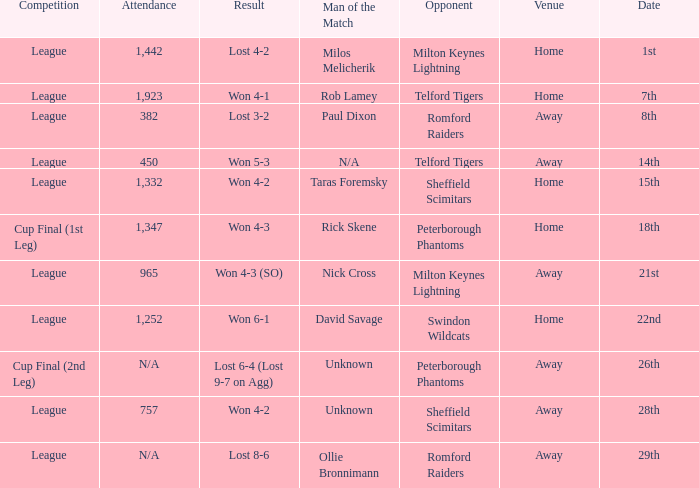What was the result on the 26th? Lost 6-4 (Lost 9-7 on Agg). 